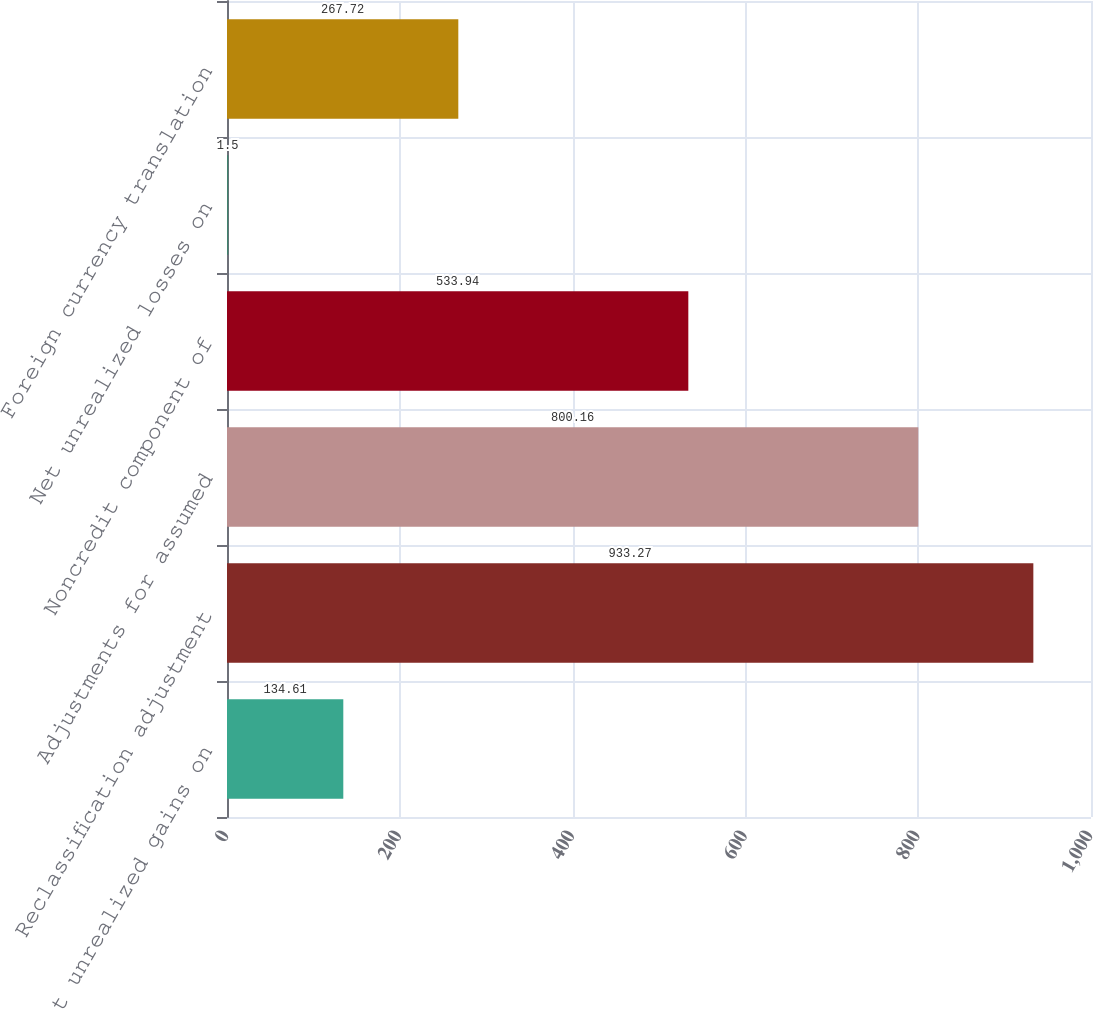<chart> <loc_0><loc_0><loc_500><loc_500><bar_chart><fcel>Net unrealized gains on<fcel>Reclassification adjustment<fcel>Adjustments for assumed<fcel>Noncredit component of<fcel>Net unrealized losses on<fcel>Foreign currency translation<nl><fcel>134.61<fcel>933.27<fcel>800.16<fcel>533.94<fcel>1.5<fcel>267.72<nl></chart> 